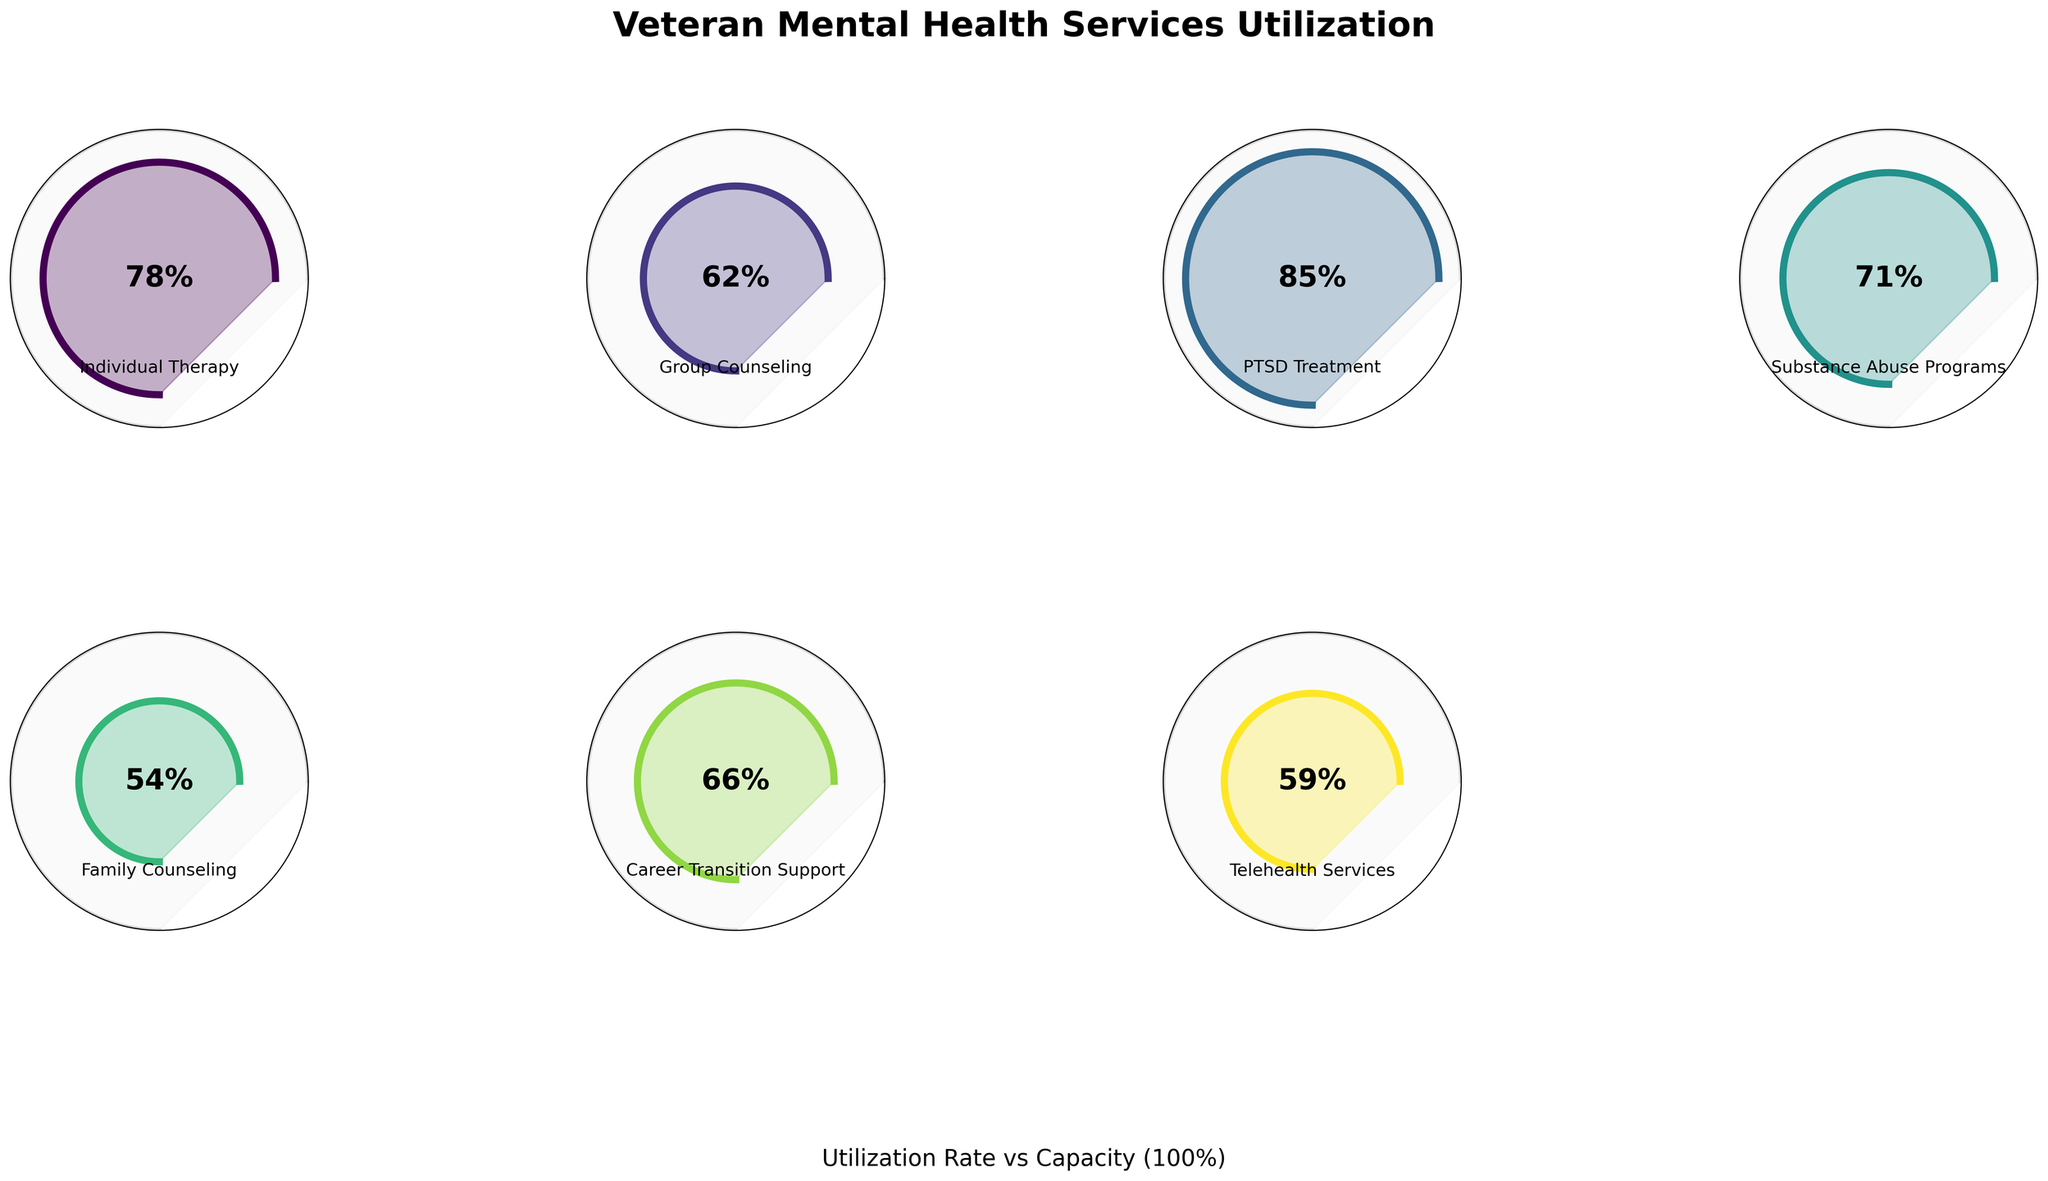What's the title of the figure? At the top of the figure, the title reads "Veteran Mental Health Services Utilization" in bold and large font size, indicating the focus of the visual representation.
Answer: Veteran Mental Health Services Utilization Which category has the highest utilization rate? By observing the utilization percentages within each gauge, the "PTSD Treatment" category shows the highest utilization rate at 85%.
Answer: PTSD Treatment What is the utilization rate for Family Counseling? Referring to the gauge for Family Counseling, the utilization rate is marked as 54%.
Answer: 54% How many categories are depicted in the figure? By counting the individual gauges for each service, the figure depicts a total of 7 categories.
Answer: 7 Compare the utilization rates of Individual Therapy and Telehealth Services. Which one is higher? By looking at the percentages within the gauges, Individual Therapy has a higher utilization rate (78%) compared to Telehealth Services (59%).
Answer: Individual Therapy Find the average utilization rate across all categories. Sum the utilization rates (78 + 62 + 85 + 71 + 54 + 66 + 59) to get 475. Divide by the number of categories (7) to find the average: 475 / 7 ≈ 67.86%.
Answer: 67.86% Which category has the lowest utilization rate? From the figures shown in each gauge, the "Family Counseling" category has the lowest utilization rate at 54%.
Answer: Family Counseling What is the gap between capacity and utilization rate for Substance Abuse Programs? Capacity is 100 for each category. The utilization rate for Substance Abuse Programs is 71. The gap is 100 - 71 = 29.
Answer: 29 Are there any categories with a utilization rate below 60%? By checking each gauge, both "Family Counseling" (54%) and "Telehealth Services" (59%) have utilization rates below 60%.
Answer: Yes What is the difference in utilization rate between Group Counseling and Career Transition Support? The utilization rate for Group Counseling is 62% and for Career Transition Support is 66%. The difference is 66 - 62 = 4.
Answer: 4 